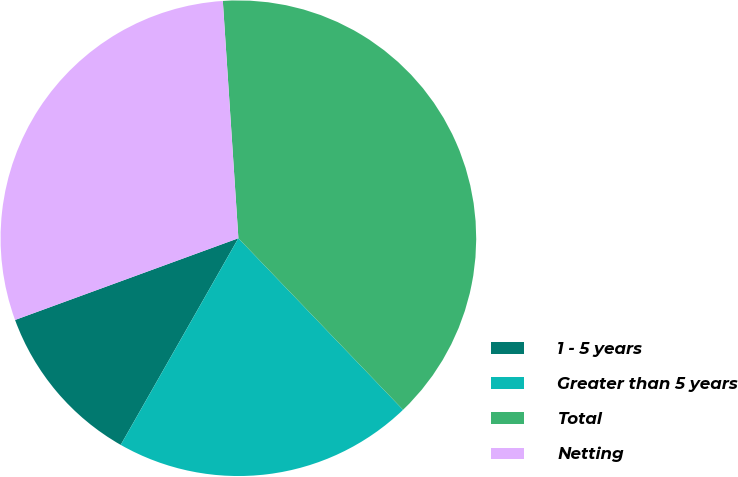Convert chart to OTSL. <chart><loc_0><loc_0><loc_500><loc_500><pie_chart><fcel>1 - 5 years<fcel>Greater than 5 years<fcel>Total<fcel>Netting<nl><fcel>11.18%<fcel>20.41%<fcel>38.87%<fcel>29.54%<nl></chart> 